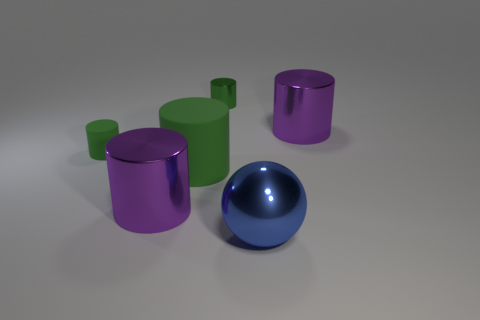Does the cylinder right of the blue thing have the same size as the big green matte cylinder?
Provide a short and direct response. Yes. Are there fewer large blue spheres than red metallic things?
Provide a short and direct response. No. What shape is the purple object to the right of the purple cylinder that is in front of the cylinder that is to the right of the metal ball?
Offer a terse response. Cylinder. Are there any tiny yellow balls made of the same material as the blue thing?
Your answer should be compact. No. Does the large cylinder right of the green shiny thing have the same color as the tiny cylinder that is on the right side of the big matte thing?
Ensure brevity in your answer.  No. Are there fewer tiny rubber cylinders in front of the blue ball than big blue rubber cubes?
Keep it short and to the point. No. What number of objects are tiny green metallic things or purple shiny cylinders to the left of the tiny green shiny object?
Ensure brevity in your answer.  2. The other small thing that is made of the same material as the blue thing is what color?
Offer a terse response. Green. What number of objects are either green rubber cylinders or big shiny cylinders?
Give a very brief answer. 4. There is a matte cylinder that is the same size as the sphere; what is its color?
Your answer should be very brief. Green. 